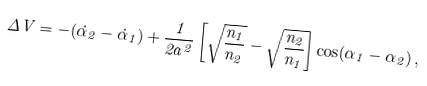<formula> <loc_0><loc_0><loc_500><loc_500>\Delta V = - ( \dot { \alpha } _ { 2 } - \dot { \alpha } _ { 1 } ) + \frac { 1 } { 2 a ^ { 2 } } \left [ \sqrt { \frac { n _ { 1 } } { n _ { 2 } } } - \sqrt { \frac { n _ { 2 } } { n _ { 1 } } } \right ] \cos ( \alpha _ { 1 } - \alpha _ { 2 } ) \, ,</formula> 